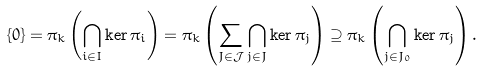Convert formula to latex. <formula><loc_0><loc_0><loc_500><loc_500>\{ 0 \} = \pi _ { k } \left ( \bigcap _ { i \in I } \ker \pi _ { i } \right ) = \pi _ { k } \left ( \sum _ { J \in \mathcal { J } } \bigcap _ { j \in J } \ker \pi _ { j } \right ) \supseteq \pi _ { k } \left ( \bigcap _ { j \in J _ { 0 } } \ker \pi _ { j } \right ) .</formula> 